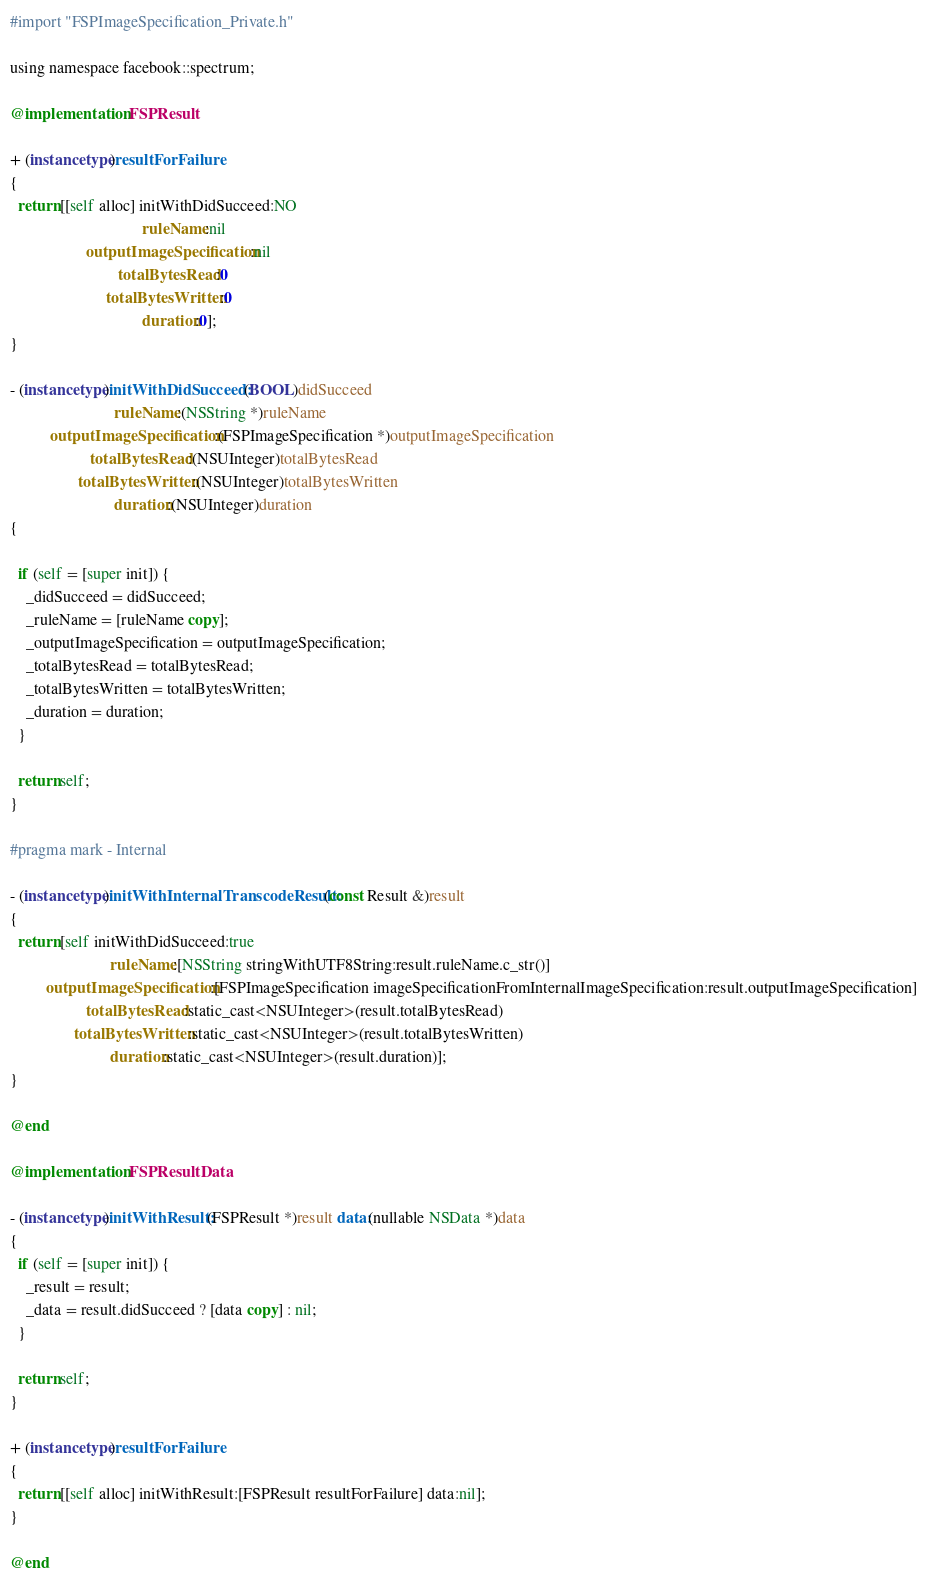<code> <loc_0><loc_0><loc_500><loc_500><_ObjectiveC_>#import "FSPImageSpecification_Private.h"

using namespace facebook::spectrum;

@implementation FSPResult

+ (instancetype)resultForFailure
{
  return [[self alloc] initWithDidSucceed:NO
                                 ruleName:nil
                   outputImageSpecification:nil
                           totalBytesRead:0
                        totalBytesWritten:0
                                 duration:0];
}

- (instancetype)initWithDidSucceed:(BOOL)didSucceed
                          ruleName:(NSString *)ruleName
          outputImageSpecification:(FSPImageSpecification *)outputImageSpecification
                    totalBytesRead:(NSUInteger)totalBytesRead
                 totalBytesWritten:(NSUInteger)totalBytesWritten
                          duration:(NSUInteger)duration
{

  if (self = [super init]) {
    _didSucceed = didSucceed;
    _ruleName = [ruleName copy];
    _outputImageSpecification = outputImageSpecification;
    _totalBytesRead = totalBytesRead;
    _totalBytesWritten = totalBytesWritten;
    _duration = duration;
  }

  return self;
}

#pragma mark - Internal

- (instancetype)initWithInternalTranscodeResult:(const Result &)result
{
  return [self initWithDidSucceed:true
                         ruleName:[NSString stringWithUTF8String:result.ruleName.c_str()]
         outputImageSpecification:[FSPImageSpecification imageSpecificationFromInternalImageSpecification:result.outputImageSpecification]
                   totalBytesRead:static_cast<NSUInteger>(result.totalBytesRead)
                totalBytesWritten:static_cast<NSUInteger>(result.totalBytesWritten)
                         duration:static_cast<NSUInteger>(result.duration)];
}

@end

@implementation FSPResultData

- (instancetype)initWithResult:(FSPResult *)result data:(nullable NSData *)data
{
  if (self = [super init]) {
    _result = result;
    _data = result.didSucceed ? [data copy] : nil;
  }

  return self;
}

+ (instancetype)resultForFailure
{
  return [[self alloc] initWithResult:[FSPResult resultForFailure] data:nil];
}

@end
</code> 